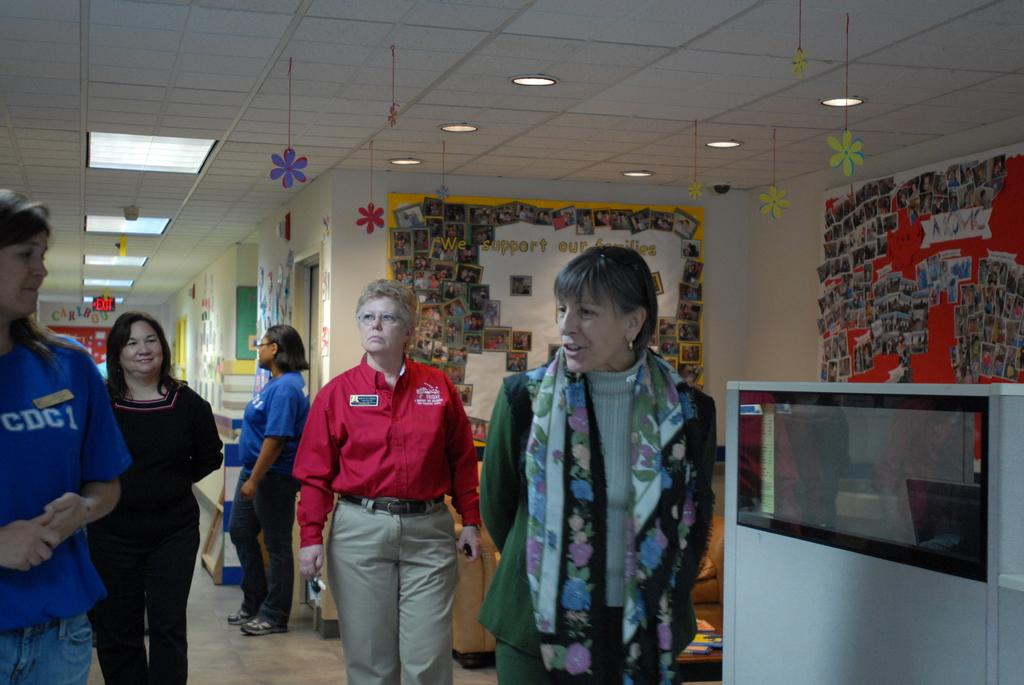Provide a one-sentence caption for the provided image. a lady standing with others and wearing a CDC1 shirt. 